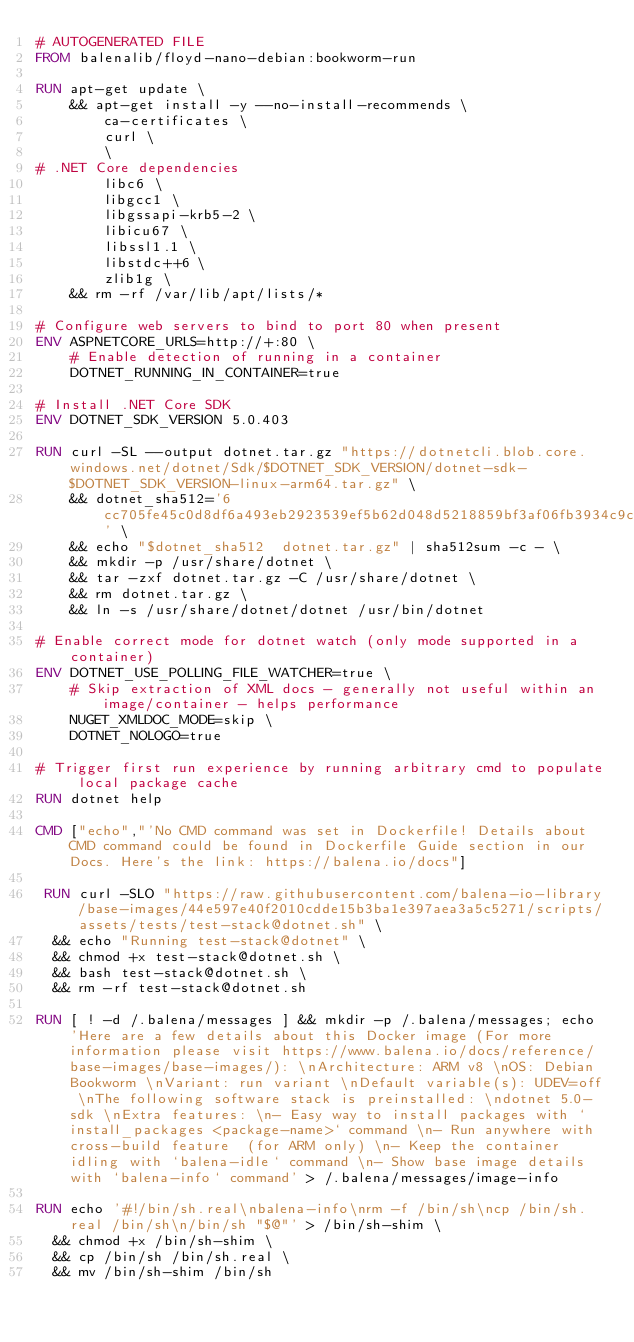<code> <loc_0><loc_0><loc_500><loc_500><_Dockerfile_># AUTOGENERATED FILE
FROM balenalib/floyd-nano-debian:bookworm-run

RUN apt-get update \
    && apt-get install -y --no-install-recommends \
        ca-certificates \
        curl \
        \
# .NET Core dependencies
        libc6 \
        libgcc1 \
        libgssapi-krb5-2 \
        libicu67 \
        libssl1.1 \
        libstdc++6 \
        zlib1g \
    && rm -rf /var/lib/apt/lists/*

# Configure web servers to bind to port 80 when present
ENV ASPNETCORE_URLS=http://+:80 \
    # Enable detection of running in a container
    DOTNET_RUNNING_IN_CONTAINER=true

# Install .NET Core SDK
ENV DOTNET_SDK_VERSION 5.0.403

RUN curl -SL --output dotnet.tar.gz "https://dotnetcli.blob.core.windows.net/dotnet/Sdk/$DOTNET_SDK_VERSION/dotnet-sdk-$DOTNET_SDK_VERSION-linux-arm64.tar.gz" \
    && dotnet_sha512='6cc705fe45c0d8df6a493eb2923539ef5b62d048d5218859bf3af06fb3934c9c716c16f98ee1a28c818d77adff8430bf39a2ae54a59a1468b704b4ba192234ac' \
    && echo "$dotnet_sha512  dotnet.tar.gz" | sha512sum -c - \
    && mkdir -p /usr/share/dotnet \
    && tar -zxf dotnet.tar.gz -C /usr/share/dotnet \
    && rm dotnet.tar.gz \
    && ln -s /usr/share/dotnet/dotnet /usr/bin/dotnet

# Enable correct mode for dotnet watch (only mode supported in a container)
ENV DOTNET_USE_POLLING_FILE_WATCHER=true \
    # Skip extraction of XML docs - generally not useful within an image/container - helps performance
    NUGET_XMLDOC_MODE=skip \
    DOTNET_NOLOGO=true

# Trigger first run experience by running arbitrary cmd to populate local package cache
RUN dotnet help

CMD ["echo","'No CMD command was set in Dockerfile! Details about CMD command could be found in Dockerfile Guide section in our Docs. Here's the link: https://balena.io/docs"]

 RUN curl -SLO "https://raw.githubusercontent.com/balena-io-library/base-images/44e597e40f2010cdde15b3ba1e397aea3a5c5271/scripts/assets/tests/test-stack@dotnet.sh" \
  && echo "Running test-stack@dotnet" \
  && chmod +x test-stack@dotnet.sh \
  && bash test-stack@dotnet.sh \
  && rm -rf test-stack@dotnet.sh 

RUN [ ! -d /.balena/messages ] && mkdir -p /.balena/messages; echo 'Here are a few details about this Docker image (For more information please visit https://www.balena.io/docs/reference/base-images/base-images/): \nArchitecture: ARM v8 \nOS: Debian Bookworm \nVariant: run variant \nDefault variable(s): UDEV=off \nThe following software stack is preinstalled: \ndotnet 5.0-sdk \nExtra features: \n- Easy way to install packages with `install_packages <package-name>` command \n- Run anywhere with cross-build feature  (for ARM only) \n- Keep the container idling with `balena-idle` command \n- Show base image details with `balena-info` command' > /.balena/messages/image-info

RUN echo '#!/bin/sh.real\nbalena-info\nrm -f /bin/sh\ncp /bin/sh.real /bin/sh\n/bin/sh "$@"' > /bin/sh-shim \
	&& chmod +x /bin/sh-shim \
	&& cp /bin/sh /bin/sh.real \
	&& mv /bin/sh-shim /bin/sh</code> 